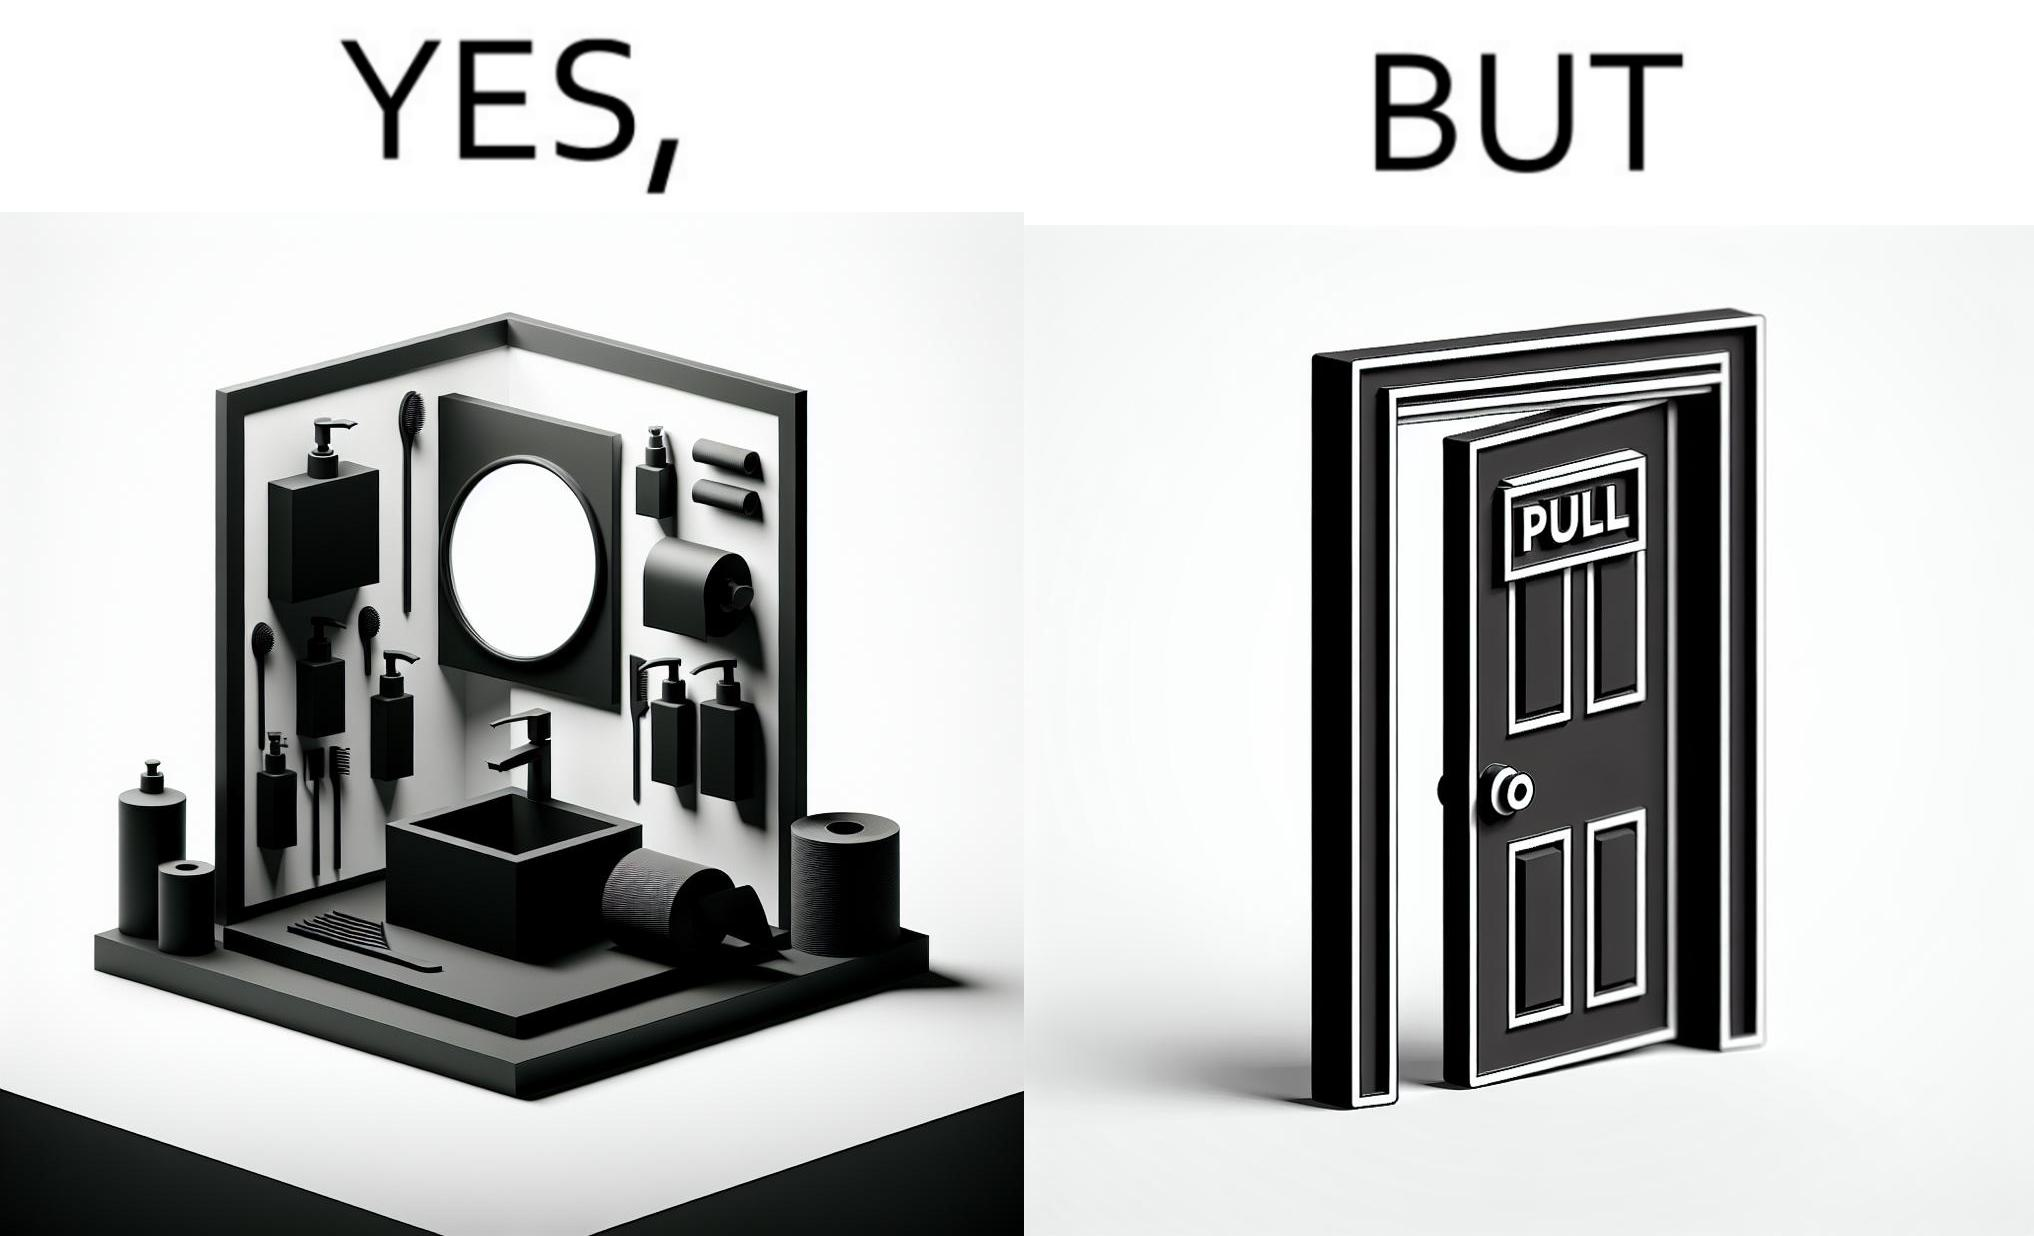What is shown in this image? The image is ironic, because in the first image in the bathroom there are so many things to clean hands around the basin but in the same bathroom people have to open the doors by hand which can easily spread the germs or bacteria even after times of hand cleaning as there is no way to open it without hands 